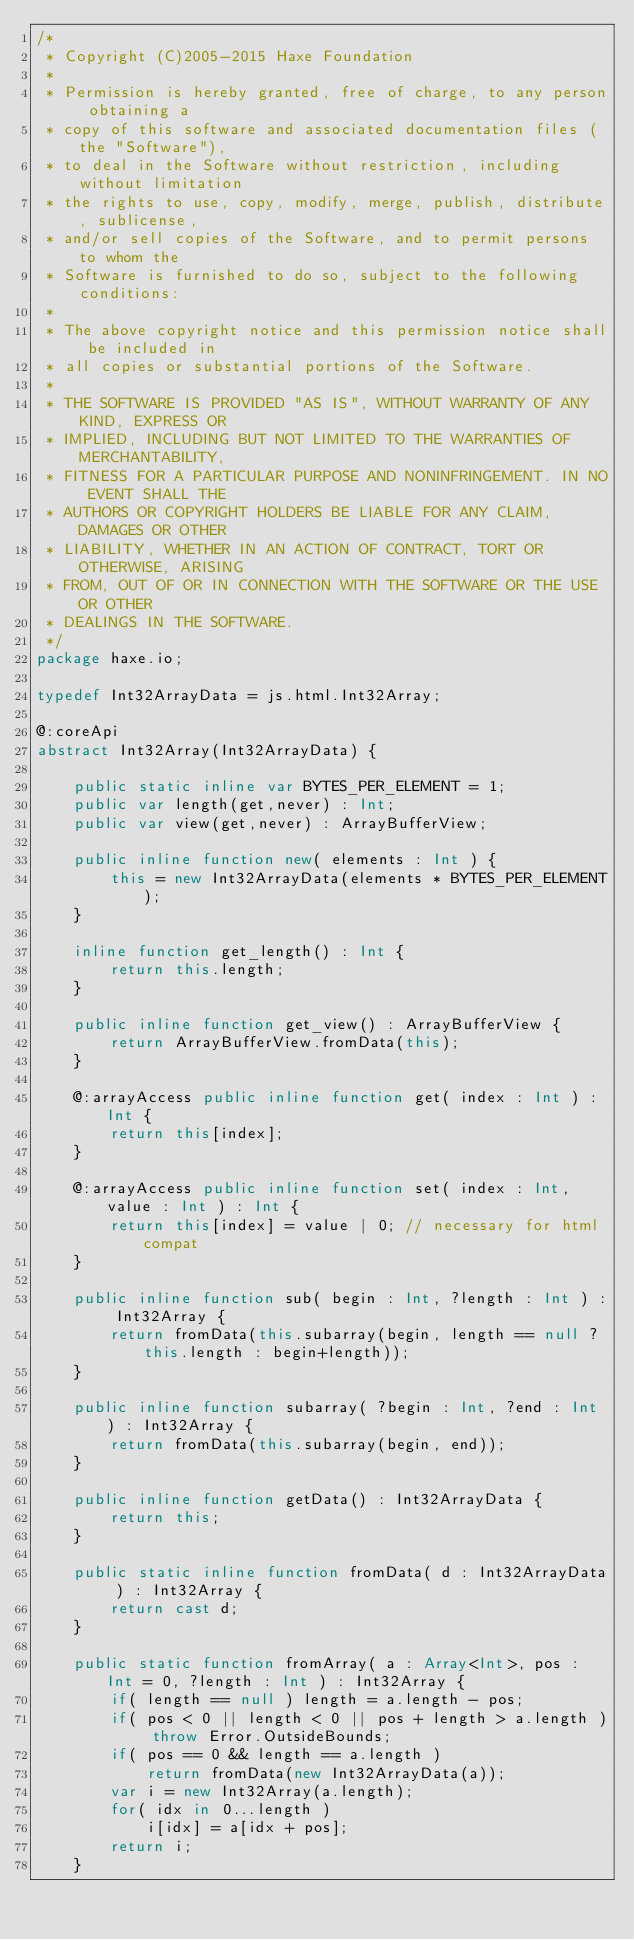<code> <loc_0><loc_0><loc_500><loc_500><_Haxe_>/*
 * Copyright (C)2005-2015 Haxe Foundation
 *
 * Permission is hereby granted, free of charge, to any person obtaining a
 * copy of this software and associated documentation files (the "Software"),
 * to deal in the Software without restriction, including without limitation
 * the rights to use, copy, modify, merge, publish, distribute, sublicense,
 * and/or sell copies of the Software, and to permit persons to whom the
 * Software is furnished to do so, subject to the following conditions:
 *
 * The above copyright notice and this permission notice shall be included in
 * all copies or substantial portions of the Software.
 *
 * THE SOFTWARE IS PROVIDED "AS IS", WITHOUT WARRANTY OF ANY KIND, EXPRESS OR
 * IMPLIED, INCLUDING BUT NOT LIMITED TO THE WARRANTIES OF MERCHANTABILITY,
 * FITNESS FOR A PARTICULAR PURPOSE AND NONINFRINGEMENT. IN NO EVENT SHALL THE
 * AUTHORS OR COPYRIGHT HOLDERS BE LIABLE FOR ANY CLAIM, DAMAGES OR OTHER
 * LIABILITY, WHETHER IN AN ACTION OF CONTRACT, TORT OR OTHERWISE, ARISING
 * FROM, OUT OF OR IN CONNECTION WITH THE SOFTWARE OR THE USE OR OTHER
 * DEALINGS IN THE SOFTWARE.
 */
package haxe.io;

typedef Int32ArrayData = js.html.Int32Array;

@:coreApi
abstract Int32Array(Int32ArrayData) {

	public static inline var BYTES_PER_ELEMENT = 1;
	public var length(get,never) : Int;
	public var view(get,never) : ArrayBufferView;

	public inline function new( elements : Int ) {
		this = new Int32ArrayData(elements * BYTES_PER_ELEMENT);
	}

	inline function get_length() : Int {
		return this.length;
	}

	public inline function get_view() : ArrayBufferView {
		return ArrayBufferView.fromData(this);
	}

	@:arrayAccess public inline function get( index : Int ) : Int {
		return this[index];
	}

	@:arrayAccess public inline function set( index : Int, value : Int ) : Int {
		return this[index] = value | 0; // necessary for html compat
	}

	public inline function sub( begin : Int, ?length : Int ) : Int32Array {
		return fromData(this.subarray(begin, length == null ? this.length : begin+length));
	}

	public inline function subarray( ?begin : Int, ?end : Int ) : Int32Array {
		return fromData(this.subarray(begin, end));
	}

	public inline function getData() : Int32ArrayData {
		return this;
	}

	public static inline function fromData( d : Int32ArrayData ) : Int32Array {
		return cast d;
	}

	public static function fromArray( a : Array<Int>, pos : Int = 0, ?length : Int ) : Int32Array {
		if( length == null ) length = a.length - pos;
		if( pos < 0 || length < 0 || pos + length > a.length ) throw Error.OutsideBounds;
		if( pos == 0 && length == a.length )
			return fromData(new Int32ArrayData(a));
		var i = new Int32Array(a.length);
		for( idx in 0...length )
			i[idx] = a[idx + pos];
		return i;
	}
</code> 